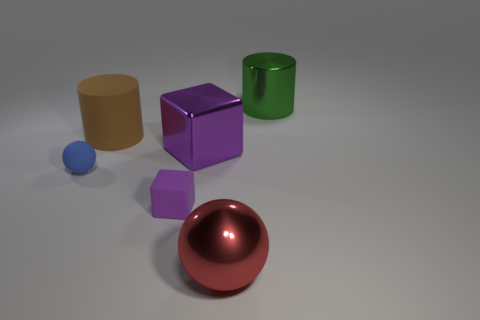Is the blue matte thing the same shape as the big purple object?
Offer a very short reply. No. How many large objects are right of the large rubber cylinder and left of the green metal thing?
Offer a very short reply. 2. Are there an equal number of tiny purple matte objects that are behind the brown matte object and purple metallic blocks that are on the right side of the blue ball?
Make the answer very short. No. There is a cylinder on the right side of the large metallic ball; does it have the same size as the matte thing right of the large brown rubber object?
Ensure brevity in your answer.  No. There is a big thing that is right of the purple shiny object and in front of the green object; what is it made of?
Your answer should be compact. Metal. Are there fewer large blue rubber cylinders than red balls?
Provide a short and direct response. Yes. There is a ball right of the sphere that is left of the metallic block; what is its size?
Offer a terse response. Large. There is a big thing on the right side of the big object that is in front of the cube in front of the blue rubber object; what shape is it?
Offer a very short reply. Cylinder. There is a large cylinder that is made of the same material as the large purple cube; what color is it?
Provide a short and direct response. Green. There is a block in front of the thing that is to the left of the large cylinder on the left side of the big green shiny object; what is its color?
Ensure brevity in your answer.  Purple. 